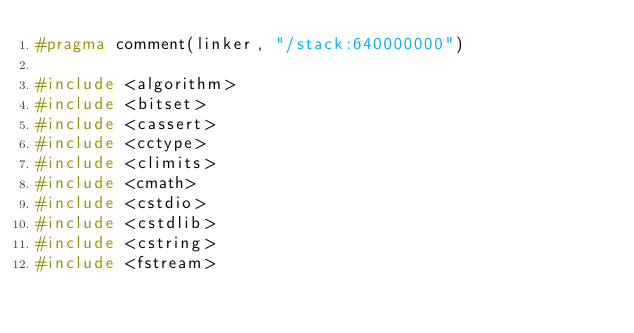<code> <loc_0><loc_0><loc_500><loc_500><_C++_>#pragma comment(linker, "/stack:640000000")

#include <algorithm>
#include <bitset>
#include <cassert>
#include <cctype>
#include <climits>
#include <cmath>
#include <cstdio>
#include <cstdlib>
#include <cstring>
#include <fstream></code> 